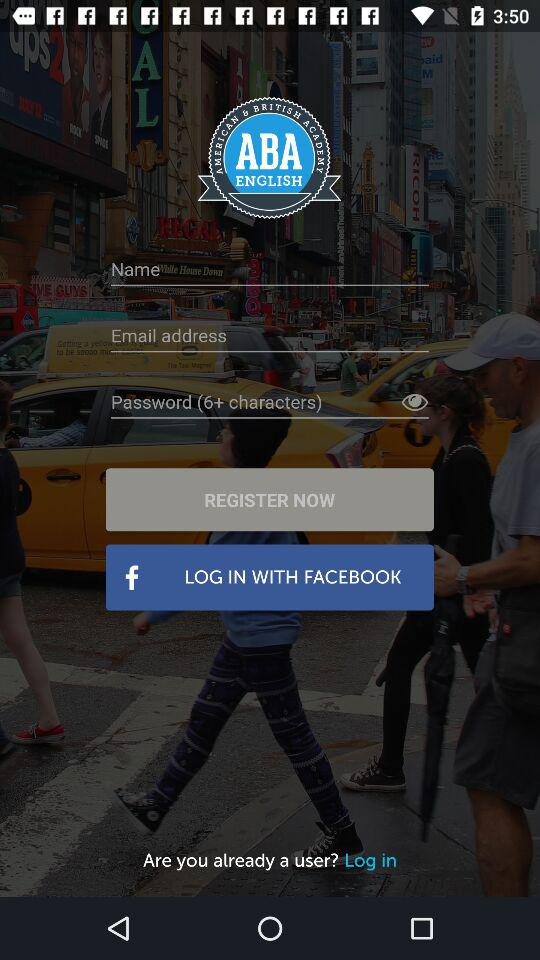How many characters are required for the password? The password requires more than 6 characters. 